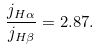<formula> <loc_0><loc_0><loc_500><loc_500>\frac { j _ { H \alpha } } { j _ { H \beta } } = 2 . 8 7 .</formula> 